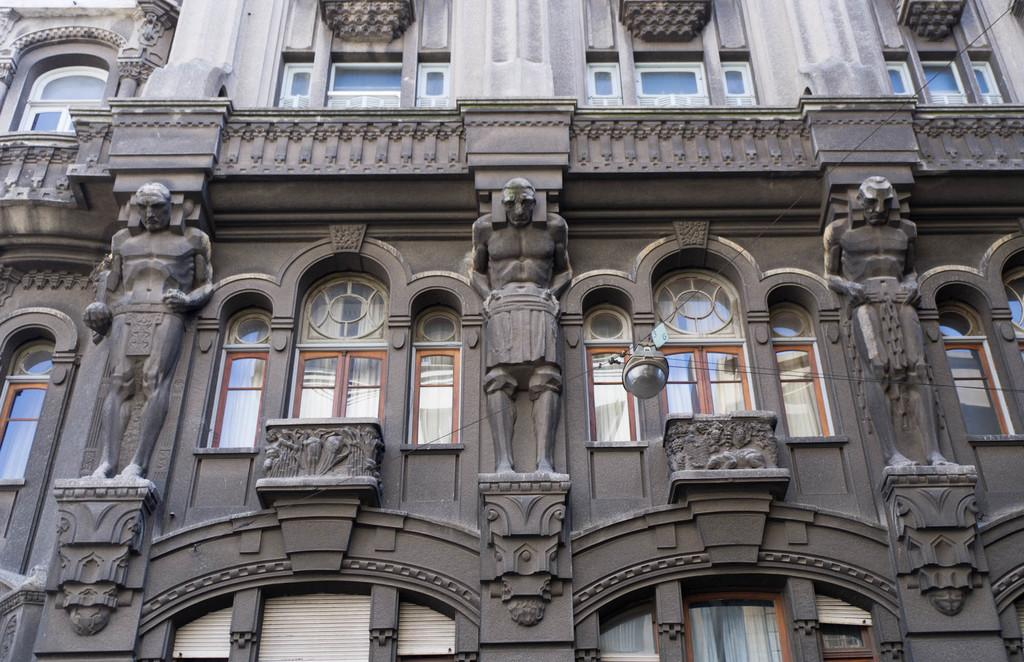What is the main structure visible in the image? There is a building in the image. What feature can be seen on the building? The building has windows. Are there any decorative elements on the building? Yes, there are statues carved on the pillars of the building. How many dimes can be seen on the roof of the building in the image? There are no dimes visible on the roof of the building in the image. 